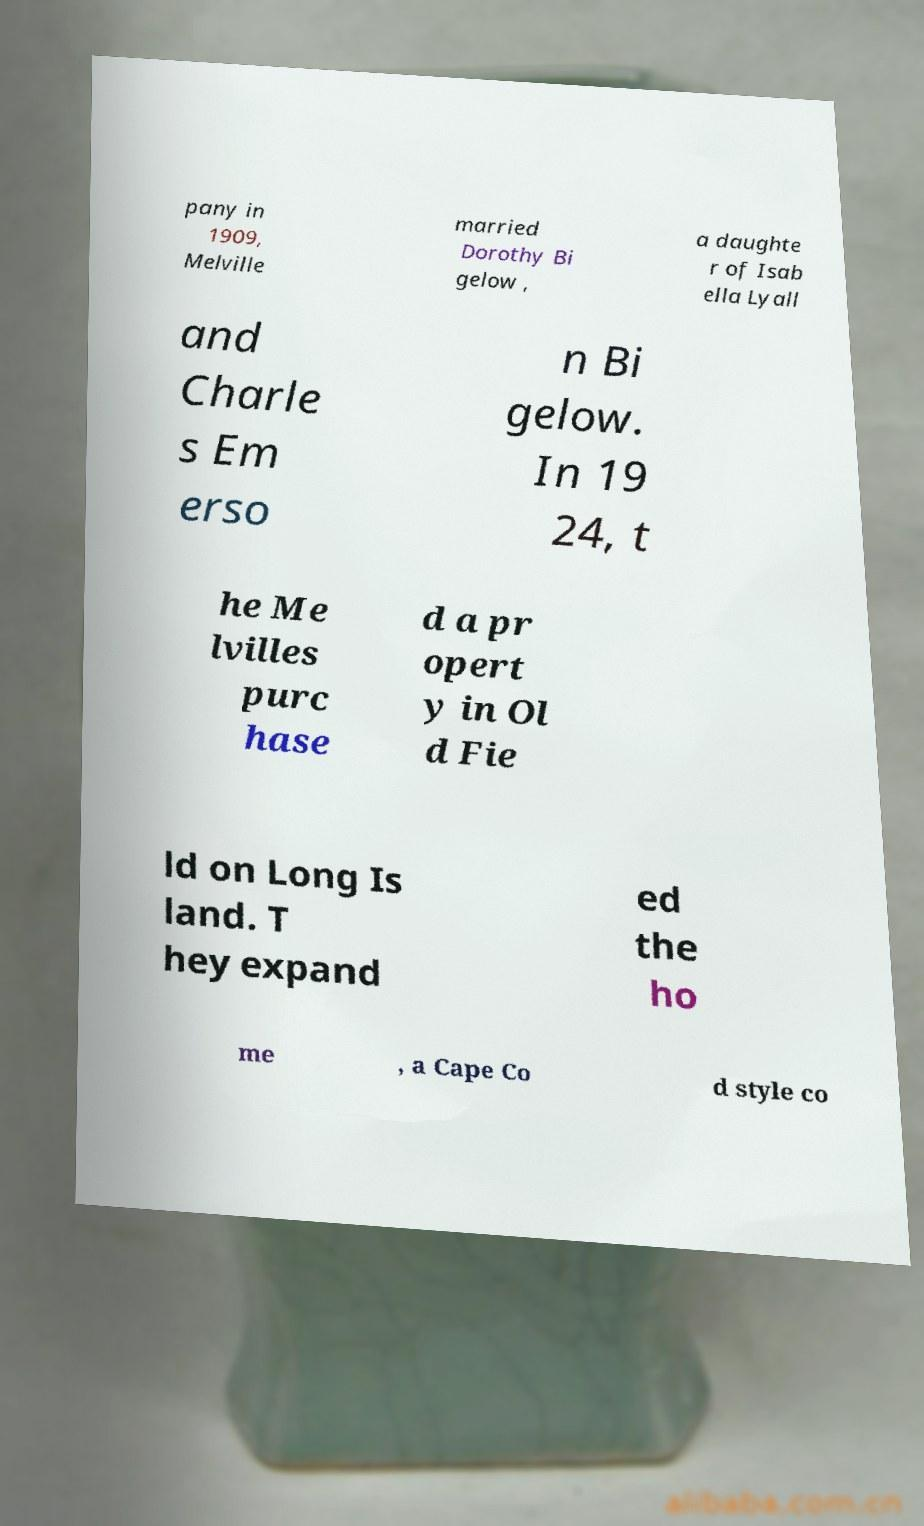What messages or text are displayed in this image? I need them in a readable, typed format. pany in 1909, Melville married Dorothy Bi gelow , a daughte r of Isab ella Lyall and Charle s Em erso n Bi gelow. In 19 24, t he Me lvilles purc hase d a pr opert y in Ol d Fie ld on Long Is land. T hey expand ed the ho me , a Cape Co d style co 